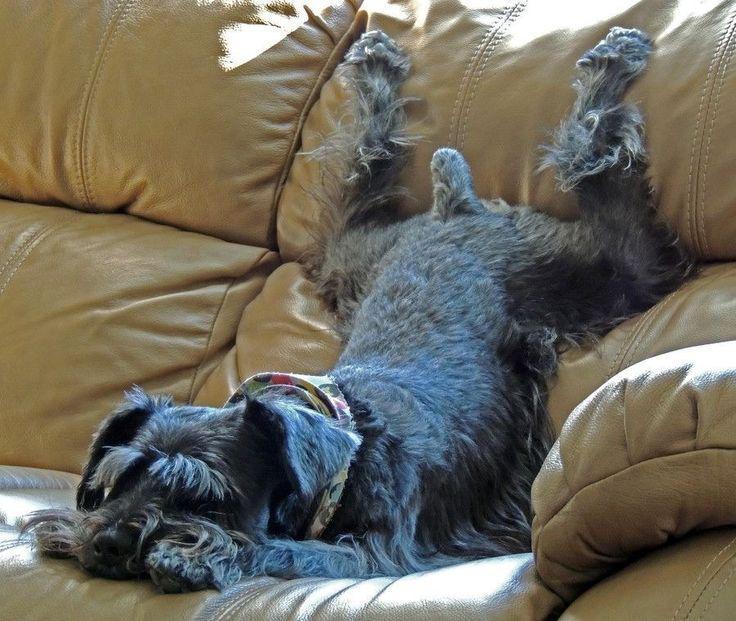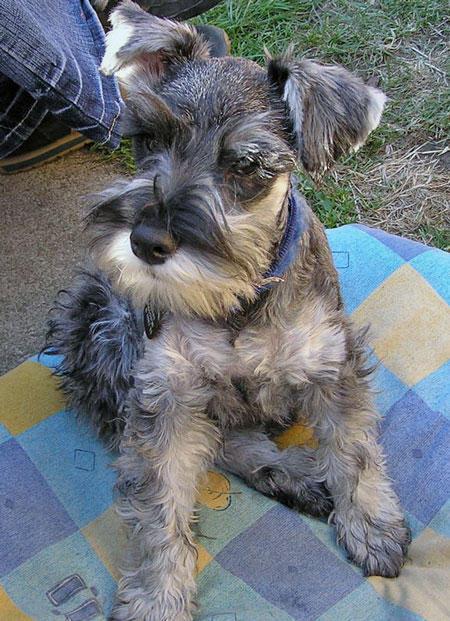The first image is the image on the left, the second image is the image on the right. Considering the images on both sides, is "There is an all white dog laying down." valid? Answer yes or no. No. The first image is the image on the left, the second image is the image on the right. Examine the images to the left and right. Is the description "A dog is sitting in one picture and in the other picture ta dog is lying down and asleep." accurate? Answer yes or no. Yes. 